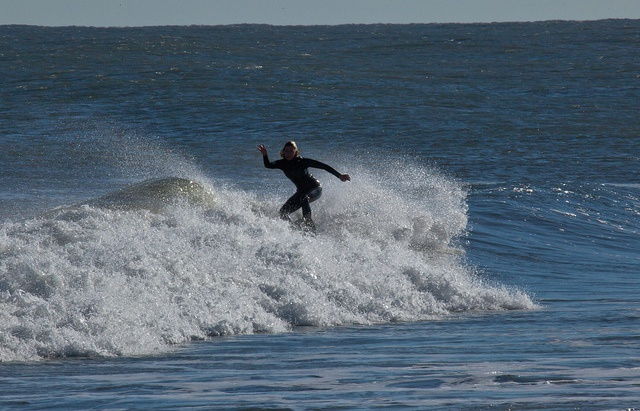Describe the objects in this image and their specific colors. I can see people in gray, black, and purple tones and surfboard in gray, darkgray, and black tones in this image. 